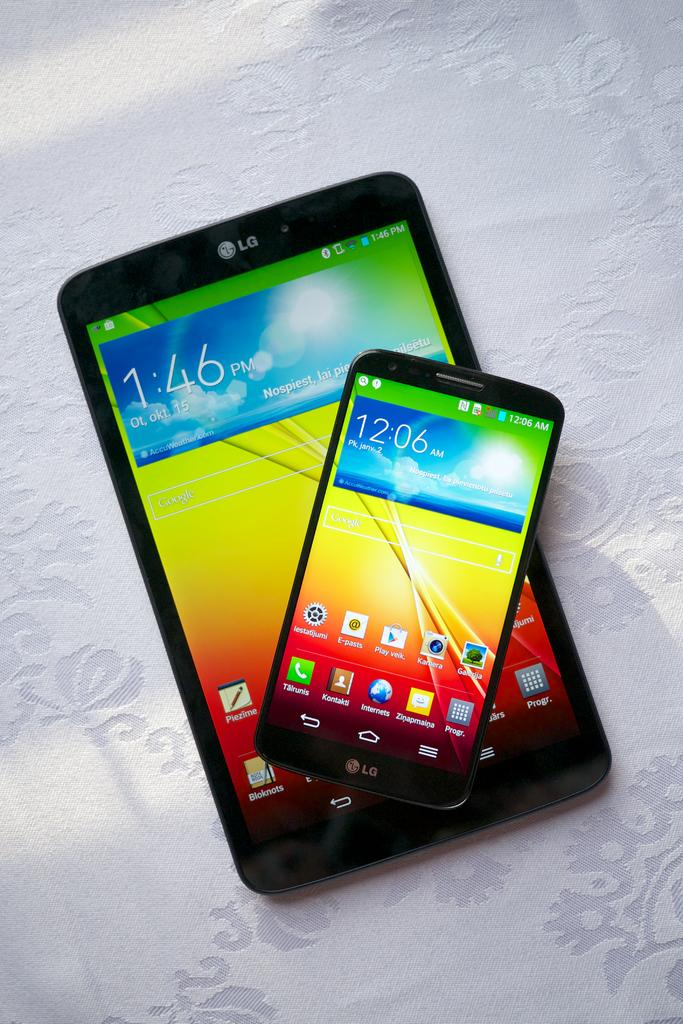What type of objects can be seen in the image? There are electronic devices in the image. Where are the electronic devices placed? The electronic devices are on a white cloth. What type of sweater is being used as an apparatus for the clam in the image? There is no sweater, apparatus, or clam present in the image. 